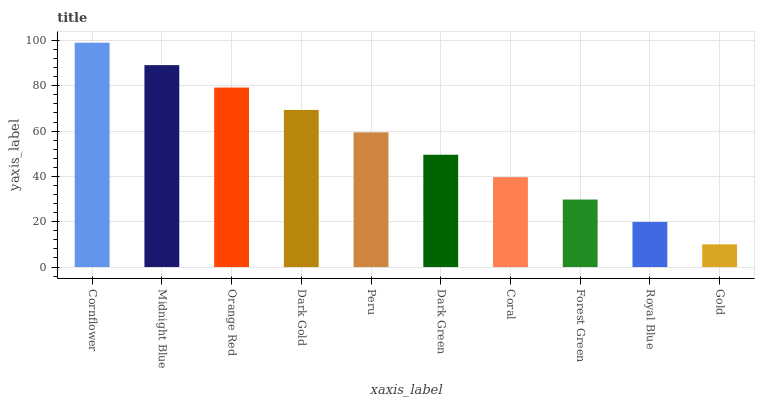Is Gold the minimum?
Answer yes or no. Yes. Is Cornflower the maximum?
Answer yes or no. Yes. Is Midnight Blue the minimum?
Answer yes or no. No. Is Midnight Blue the maximum?
Answer yes or no. No. Is Cornflower greater than Midnight Blue?
Answer yes or no. Yes. Is Midnight Blue less than Cornflower?
Answer yes or no. Yes. Is Midnight Blue greater than Cornflower?
Answer yes or no. No. Is Cornflower less than Midnight Blue?
Answer yes or no. No. Is Peru the high median?
Answer yes or no. Yes. Is Dark Green the low median?
Answer yes or no. Yes. Is Midnight Blue the high median?
Answer yes or no. No. Is Dark Gold the low median?
Answer yes or no. No. 